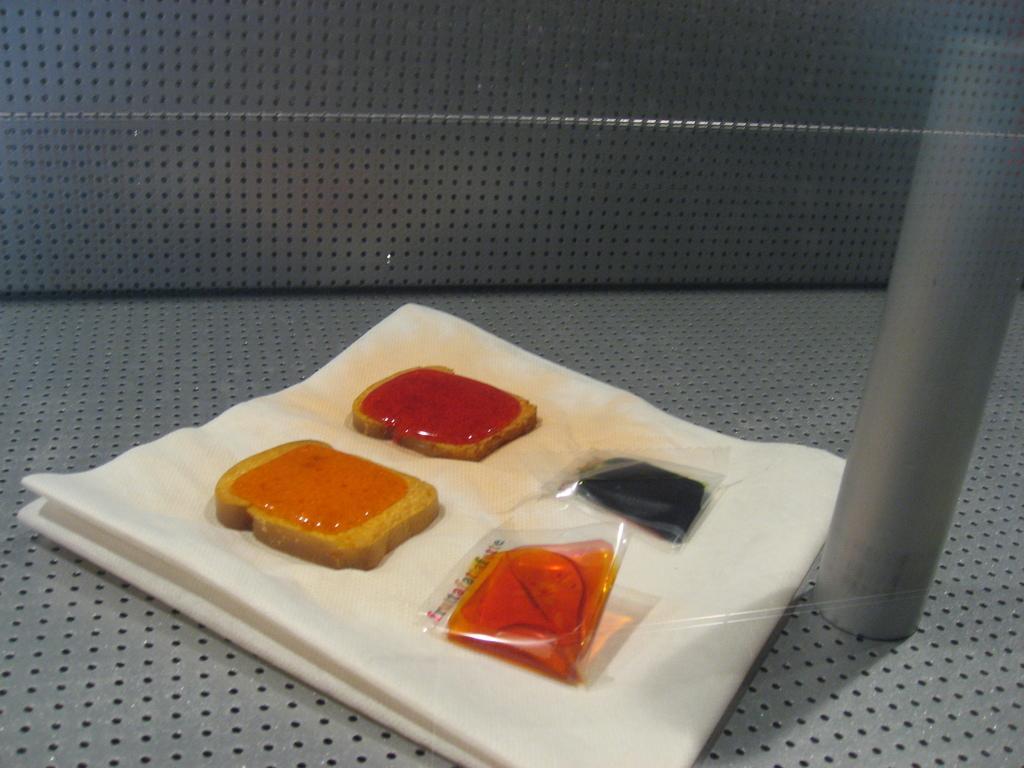How would you summarize this image in a sentence or two? In this picture there is a bread jam, honey and other objects on the white cloth. In the back we can see couch. 